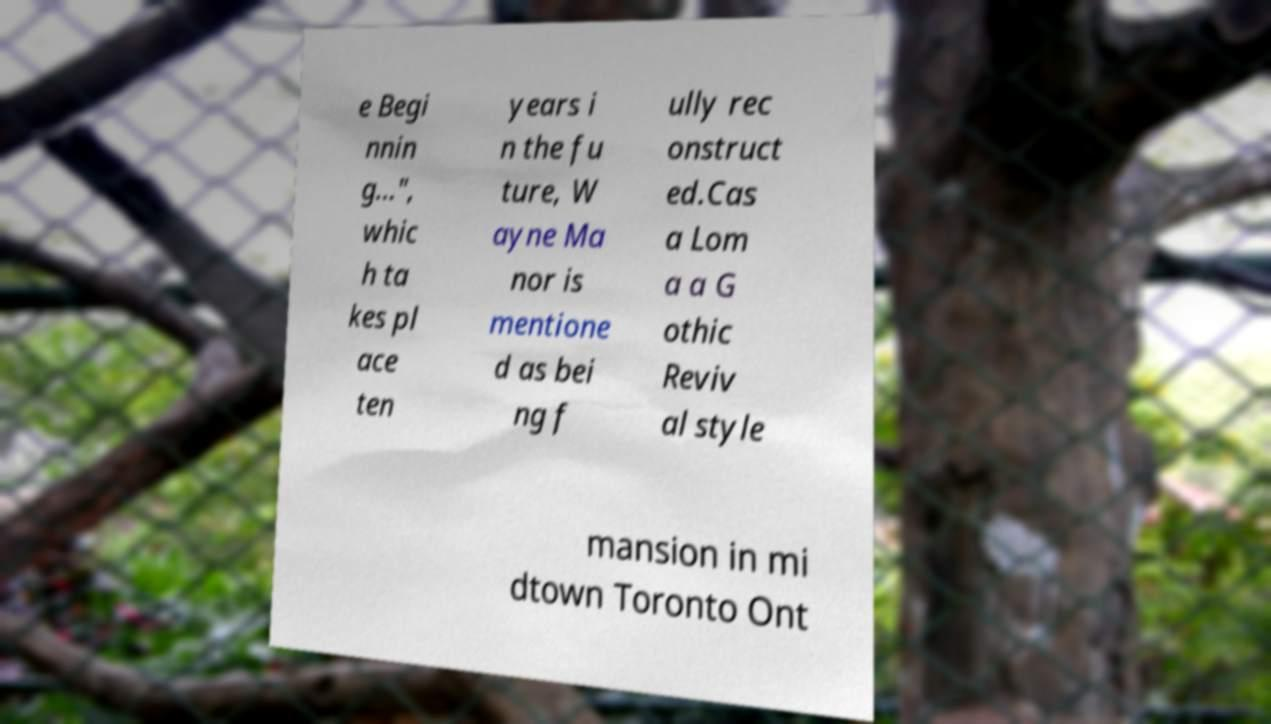What messages or text are displayed in this image? I need them in a readable, typed format. e Begi nnin g...", whic h ta kes pl ace ten years i n the fu ture, W ayne Ma nor is mentione d as bei ng f ully rec onstruct ed.Cas a Lom a a G othic Reviv al style mansion in mi dtown Toronto Ont 